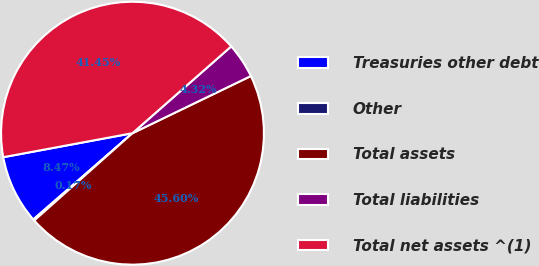Convert chart. <chart><loc_0><loc_0><loc_500><loc_500><pie_chart><fcel>Treasuries other debt<fcel>Other<fcel>Total assets<fcel>Total liabilities<fcel>Total net assets ^(1)<nl><fcel>8.47%<fcel>0.17%<fcel>45.6%<fcel>4.32%<fcel>41.45%<nl></chart> 